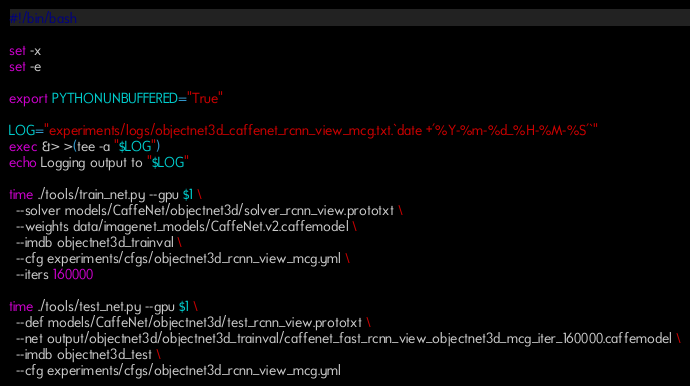<code> <loc_0><loc_0><loc_500><loc_500><_Bash_>#!/bin/bash

set -x
set -e

export PYTHONUNBUFFERED="True"

LOG="experiments/logs/objectnet3d_caffenet_rcnn_view_mcg.txt.`date +'%Y-%m-%d_%H-%M-%S'`"
exec &> >(tee -a "$LOG")
echo Logging output to "$LOG"

time ./tools/train_net.py --gpu $1 \
  --solver models/CaffeNet/objectnet3d/solver_rcnn_view.prototxt \
  --weights data/imagenet_models/CaffeNet.v2.caffemodel \
  --imdb objectnet3d_trainval \
  --cfg experiments/cfgs/objectnet3d_rcnn_view_mcg.yml \
  --iters 160000

time ./tools/test_net.py --gpu $1 \
  --def models/CaffeNet/objectnet3d/test_rcnn_view.prototxt \
  --net output/objectnet3d/objectnet3d_trainval/caffenet_fast_rcnn_view_objectnet3d_mcg_iter_160000.caffemodel \
  --imdb objectnet3d_test \
  --cfg experiments/cfgs/objectnet3d_rcnn_view_mcg.yml
</code> 